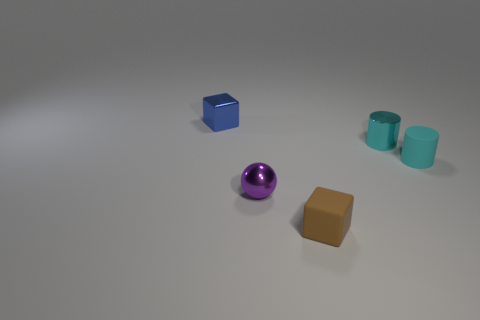Add 4 big red rubber blocks. How many objects exist? 9 Subtract all cubes. How many objects are left? 3 Add 5 brown things. How many brown things exist? 6 Subtract 0 yellow cylinders. How many objects are left? 5 Subtract all matte cylinders. Subtract all cyan cylinders. How many objects are left? 2 Add 3 cyan objects. How many cyan objects are left? 5 